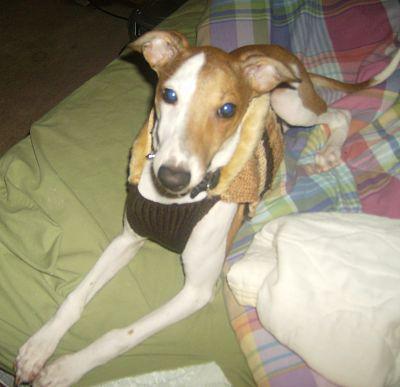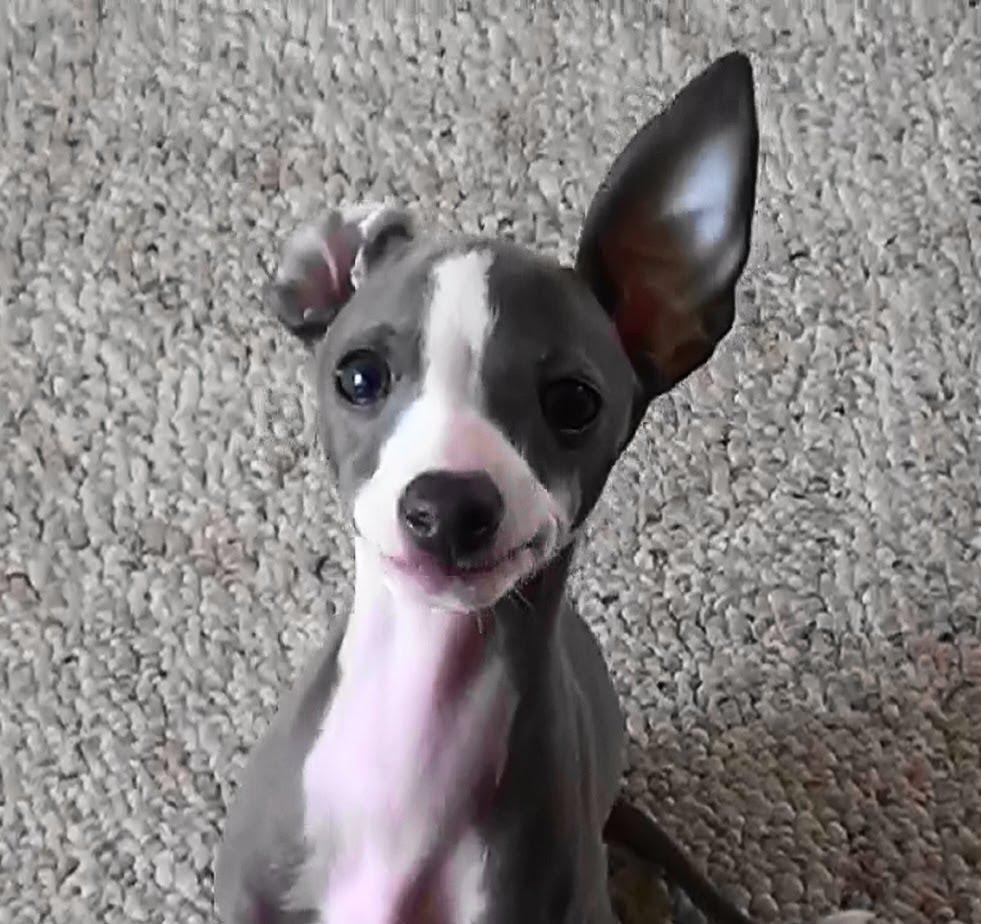The first image is the image on the left, the second image is the image on the right. Analyze the images presented: Is the assertion "There are two dogs in total" valid? Answer yes or no. Yes. The first image is the image on the left, the second image is the image on the right. For the images shown, is this caption "An image shows just one hound, reclining with paws extended forward." true? Answer yes or no. Yes. 